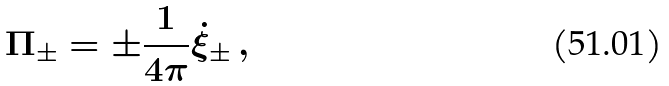<formula> <loc_0><loc_0><loc_500><loc_500>\Pi _ { \pm } = \pm { \frac { 1 } { 4 \pi } } \dot { \xi } _ { \pm } \, ,</formula> 